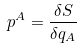Convert formula to latex. <formula><loc_0><loc_0><loc_500><loc_500>p ^ { A } = \frac { \delta S } { \delta q _ { A } }</formula> 